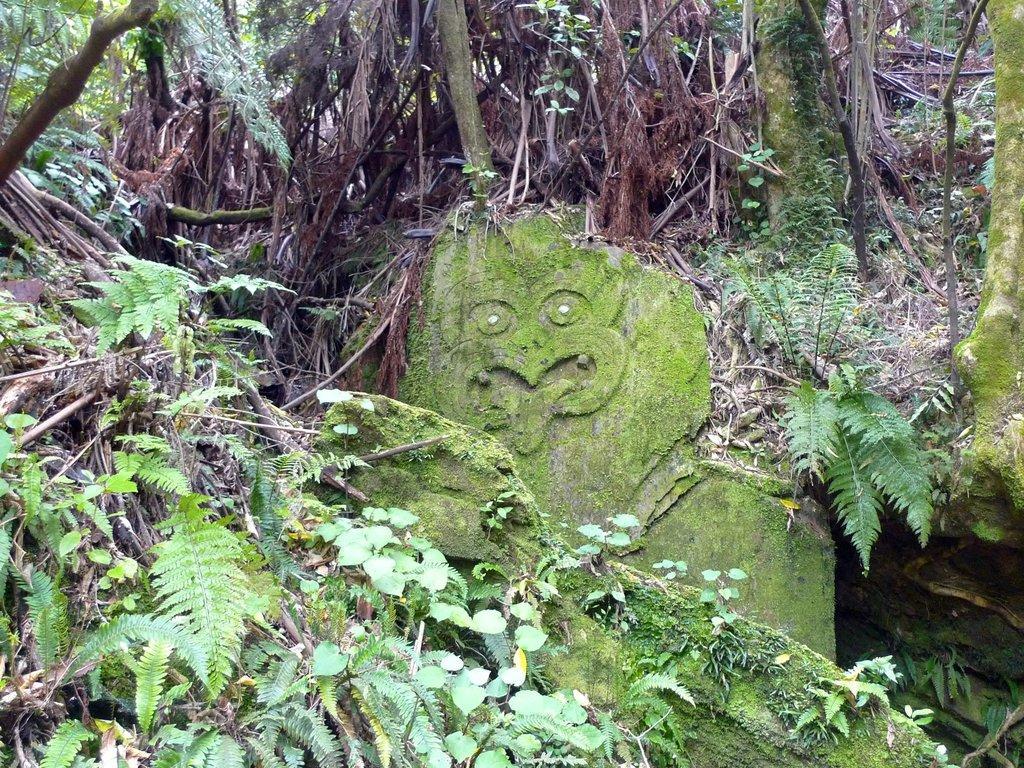Please provide a concise description of this image. In the image there is a stone idol in the middle with plants and trees on either side of it. 